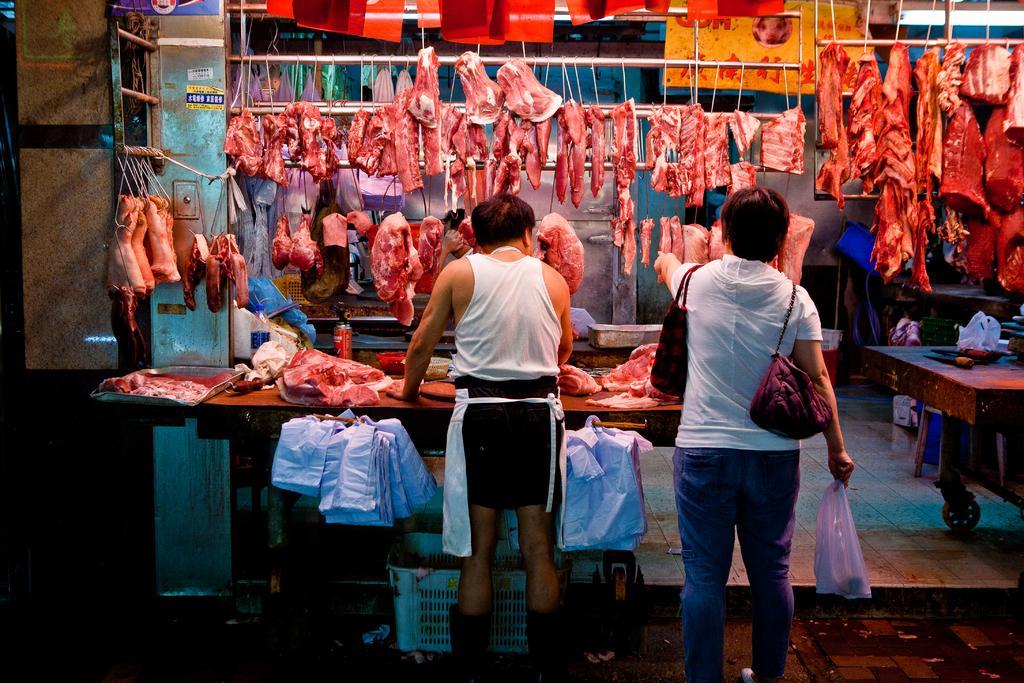Could you give a brief overview of what you see in this image? This picture is taken in the meat shop. In the center, there is a table. Beside the table, there is a man and a woman. Both of them are wearing white tops. Woman is carrying bags and holding a cover. On the table, there is meat. On the top, there is meat hanged to the rods. 